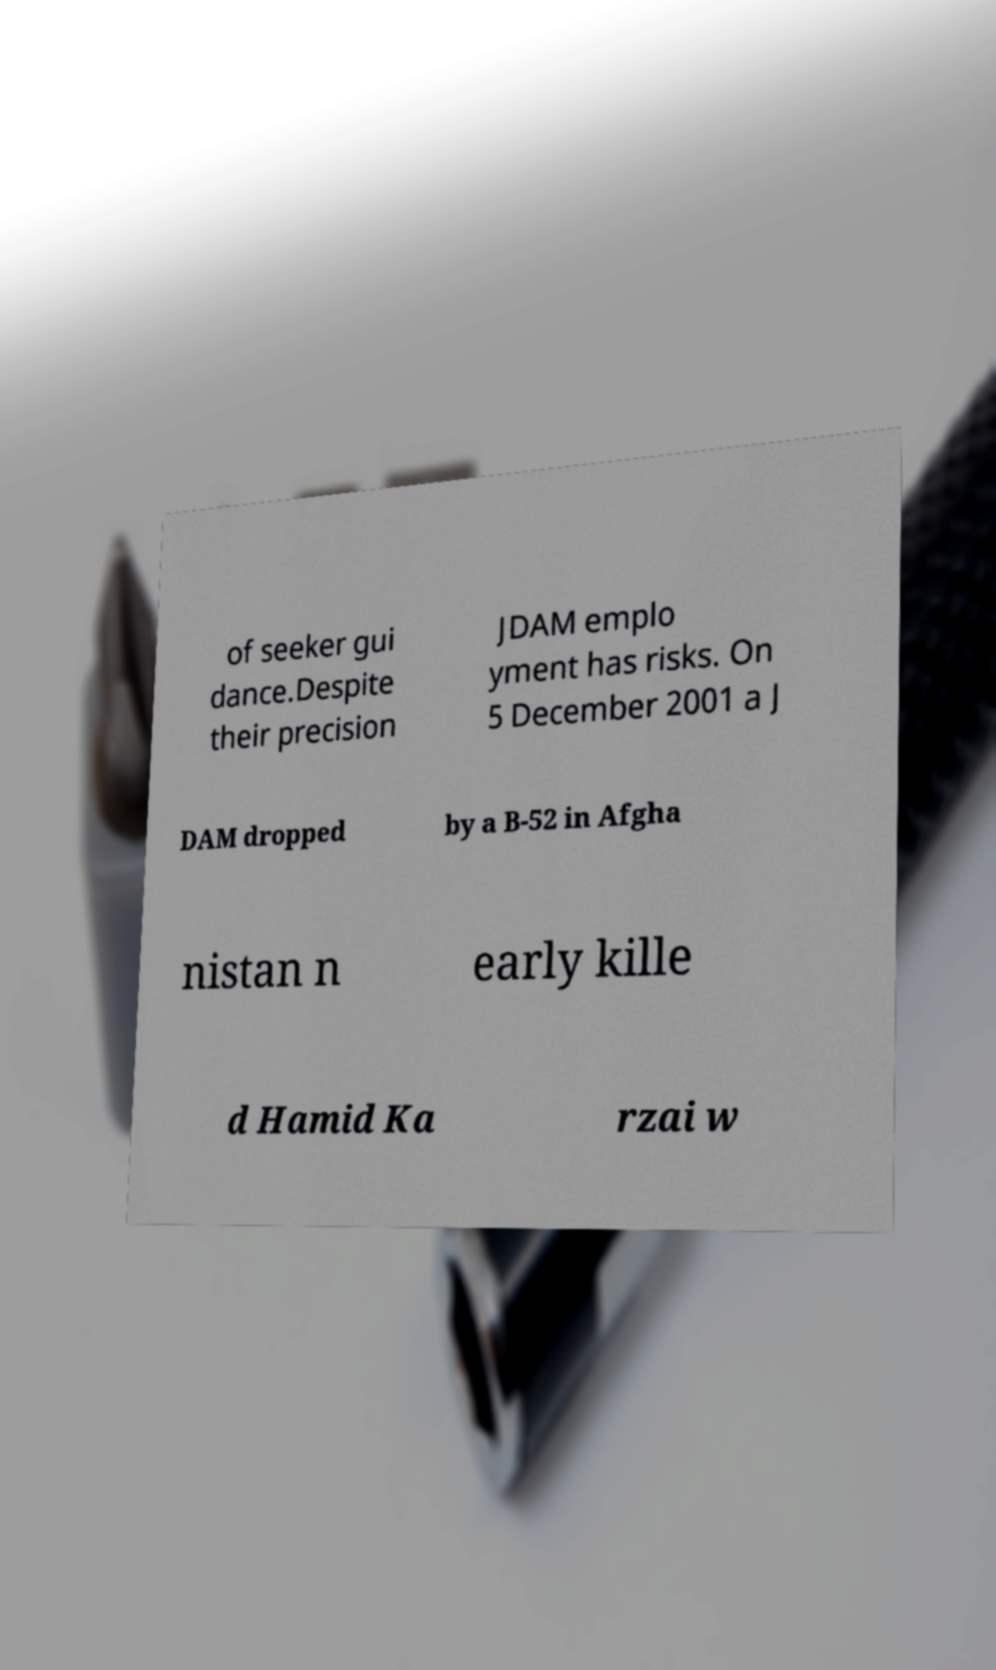Please read and relay the text visible in this image. What does it say? of seeker gui dance.Despite their precision JDAM emplo yment has risks. On 5 December 2001 a J DAM dropped by a B-52 in Afgha nistan n early kille d Hamid Ka rzai w 